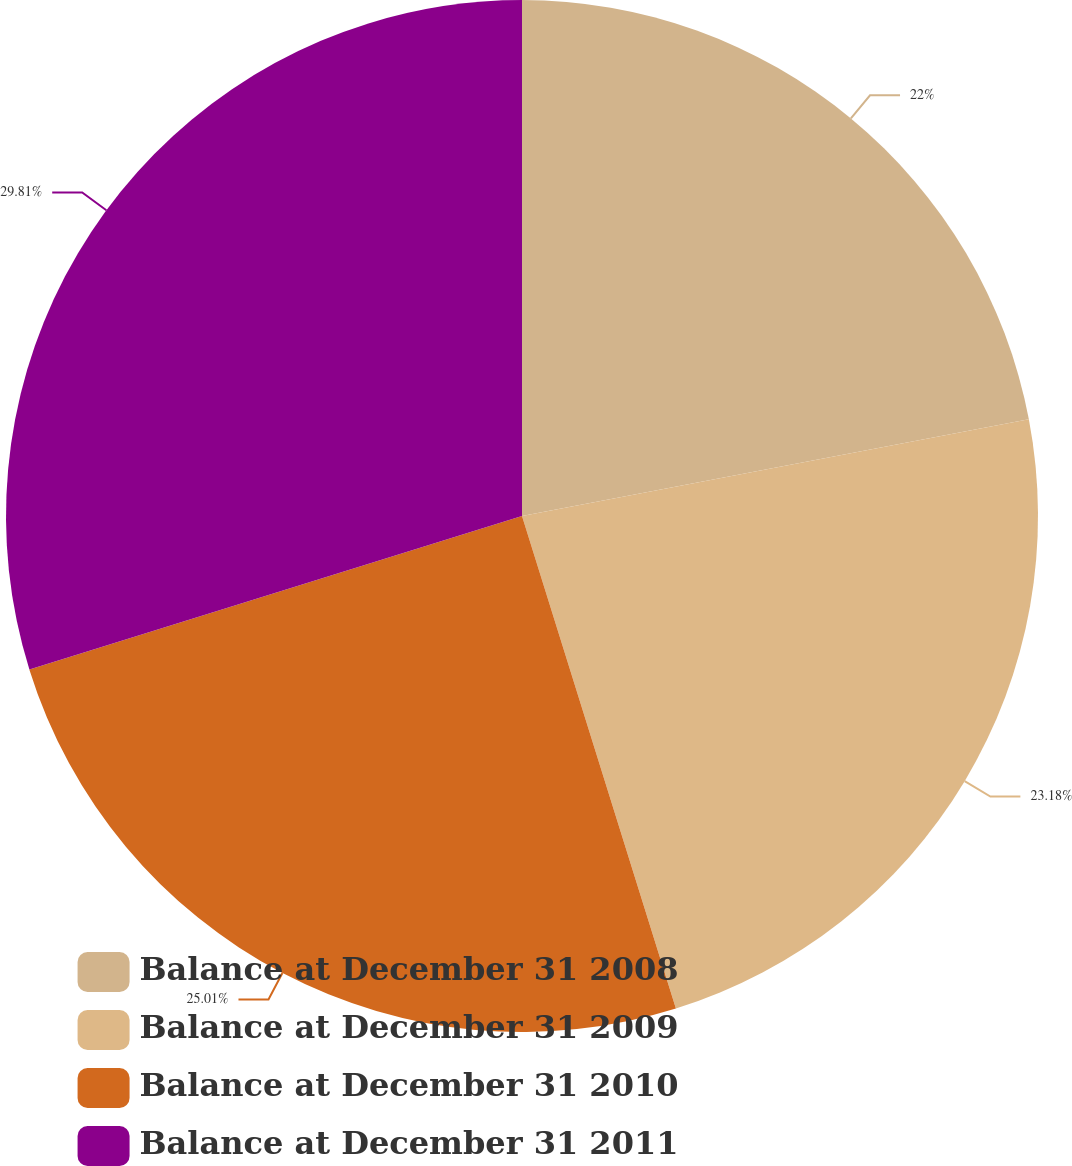Convert chart to OTSL. <chart><loc_0><loc_0><loc_500><loc_500><pie_chart><fcel>Balance at December 31 2008<fcel>Balance at December 31 2009<fcel>Balance at December 31 2010<fcel>Balance at December 31 2011<nl><fcel>22.0%<fcel>23.18%<fcel>25.01%<fcel>29.81%<nl></chart> 